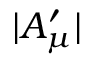<formula> <loc_0><loc_0><loc_500><loc_500>| A _ { \mu } ^ { \prime } |</formula> 